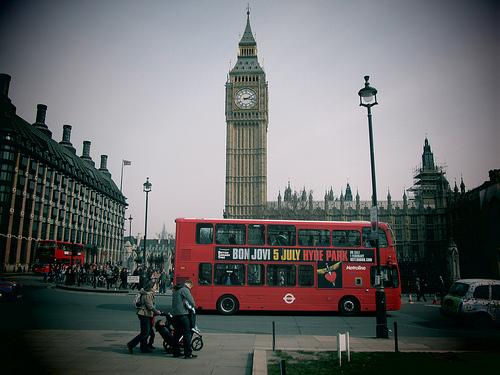What type of famous building is partially visible in the image and what feature does it have? The Tower of London is shown in the image, featuring a tall clocktower with a round clockface. Describe an element in the image related to street lighting. There is a tall street lamp in the image, which is not lit. Discuss any noticeable objects or features placed on the ground in the picture. A round, black tire, a small white sign on grass, and a cone in the street are visible on the ground. What does the white sign on the grass signify? The small white sign on the grass is unreadable, but it stands out in contrast to the green grass. Identify any signage or text in the image related to a park. The words "Hyde Park" are written in red lettering in the picture. What activity are people engaged in near the bus? People are walking on the sidewalk, some pushing strollers. Mention the type of vehicle dominating the image and its color. A red double-decker bus is the main focus in the picture. Describe the weather in the picture. The sky appears to be partly cloudy in the image, taken during the day. What is the distinguishing feature of the red bus? The bus has two stories, making it a double-decker bus. State a significant feature depicted on the side of the double-decker bus. On the side of the bus, there is a black ad sign with distorted colorful text. 